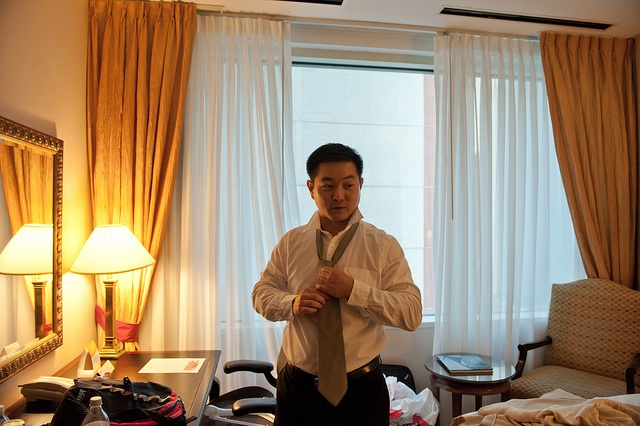Describe the objects in this image and their specific colors. I can see people in brown, maroon, black, and gray tones, chair in brown, maroon, gray, and black tones, backpack in brown, black, maroon, and gray tones, tie in brown, maroon, black, and gray tones, and chair in brown, black, darkgray, gray, and maroon tones in this image. 